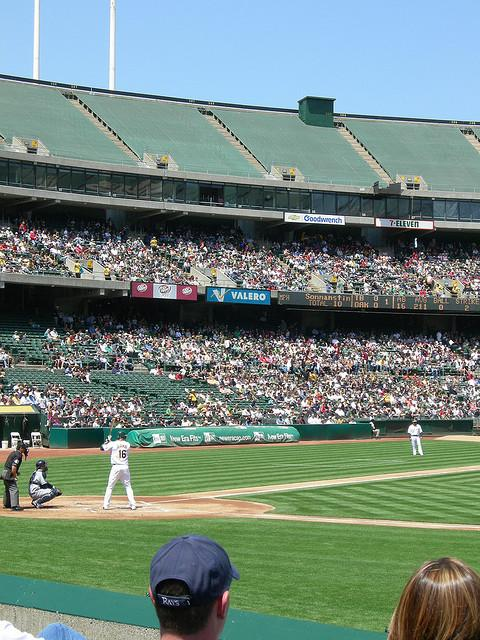The man wearing what color of shirt enforces the rules of the game? black 